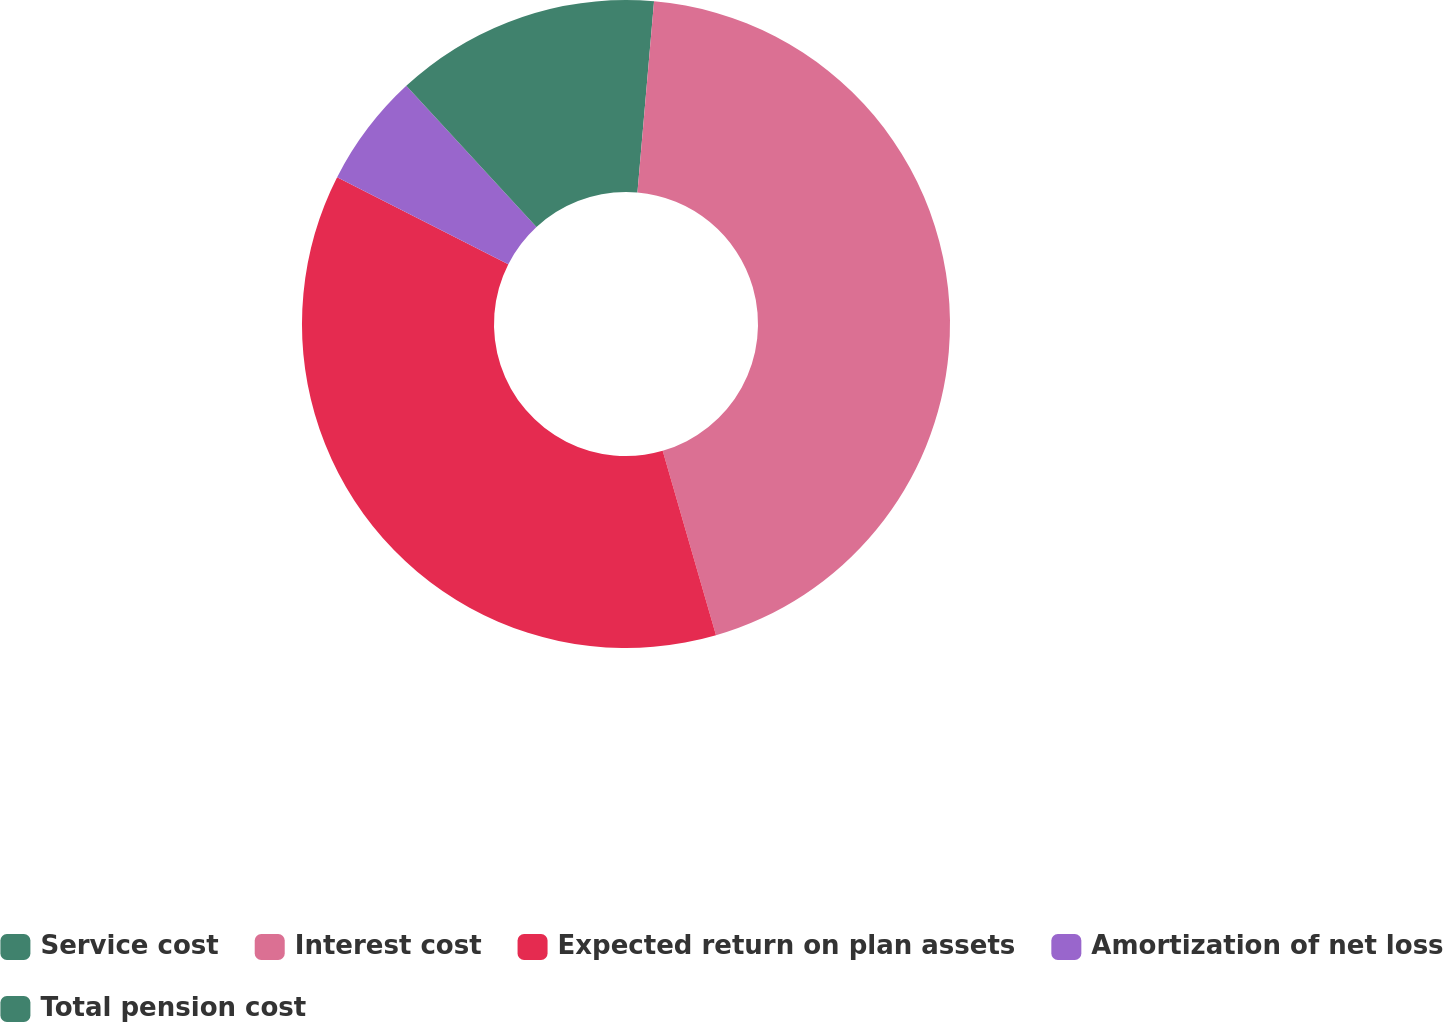Convert chart. <chart><loc_0><loc_0><loc_500><loc_500><pie_chart><fcel>Service cost<fcel>Interest cost<fcel>Expected return on plan assets<fcel>Amortization of net loss<fcel>Total pension cost<nl><fcel>1.38%<fcel>44.14%<fcel>36.96%<fcel>5.66%<fcel>11.86%<nl></chart> 